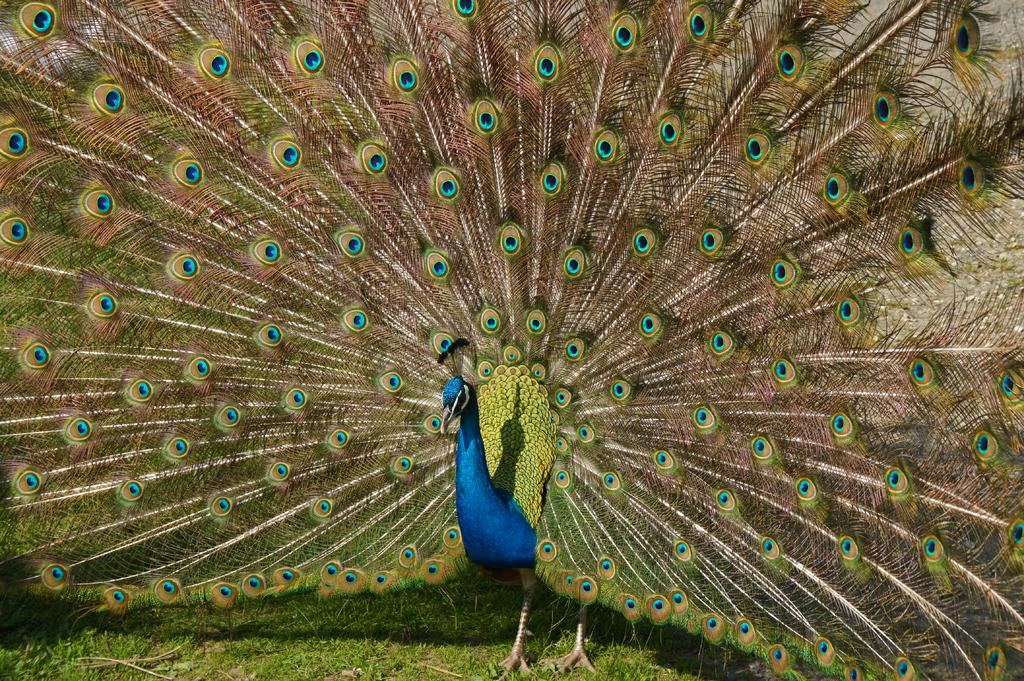What type of animal is in the image? There is a peacock in the image. Where is the peacock located? The peacock is on the grass. What type of floor can be seen in the image? There is no floor visible in the image; it features a peacock on the grass. Who is the writer of the image? The image does not have a writer, as it is a photograph or illustration and not a written work. 